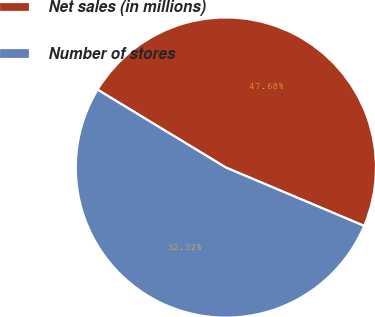Convert chart. <chart><loc_0><loc_0><loc_500><loc_500><pie_chart><fcel>Net sales (in millions)<fcel>Number of stores<nl><fcel>47.68%<fcel>52.32%<nl></chart> 